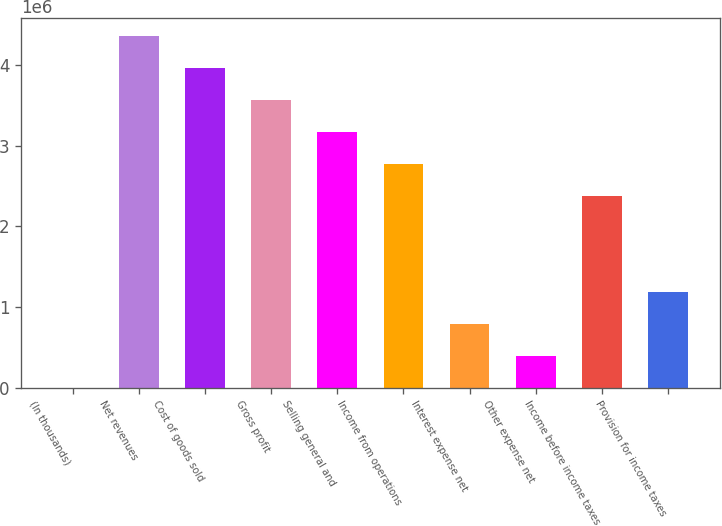<chart> <loc_0><loc_0><loc_500><loc_500><bar_chart><fcel>(In thousands)<fcel>Net revenues<fcel>Cost of goods sold<fcel>Gross profit<fcel>Selling general and<fcel>Income from operations<fcel>Interest expense net<fcel>Other expense net<fcel>Income before income taxes<fcel>Provision for income taxes<nl><fcel>2015<fcel>4.35944e+06<fcel>3.96331e+06<fcel>3.56718e+06<fcel>3.17105e+06<fcel>2.77492e+06<fcel>794275<fcel>398145<fcel>2.37879e+06<fcel>1.1904e+06<nl></chart> 